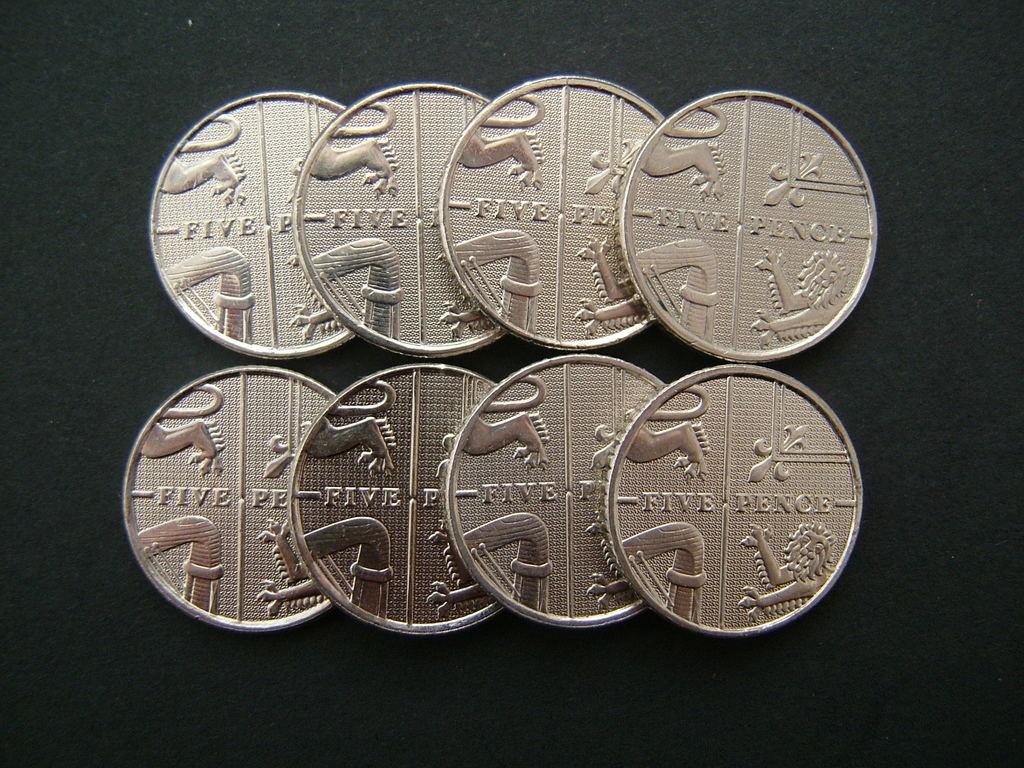How much is each individual coin worth?
Provide a succinct answer. Five pence. 